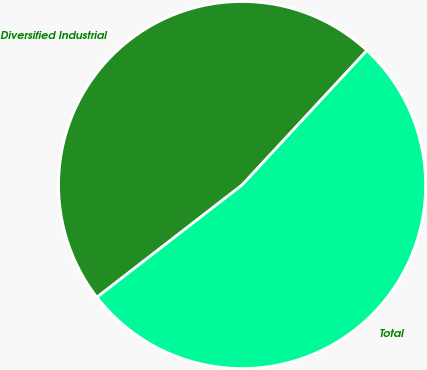Convert chart. <chart><loc_0><loc_0><loc_500><loc_500><pie_chart><fcel>Diversified Industrial<fcel>Total<nl><fcel>47.38%<fcel>52.62%<nl></chart> 